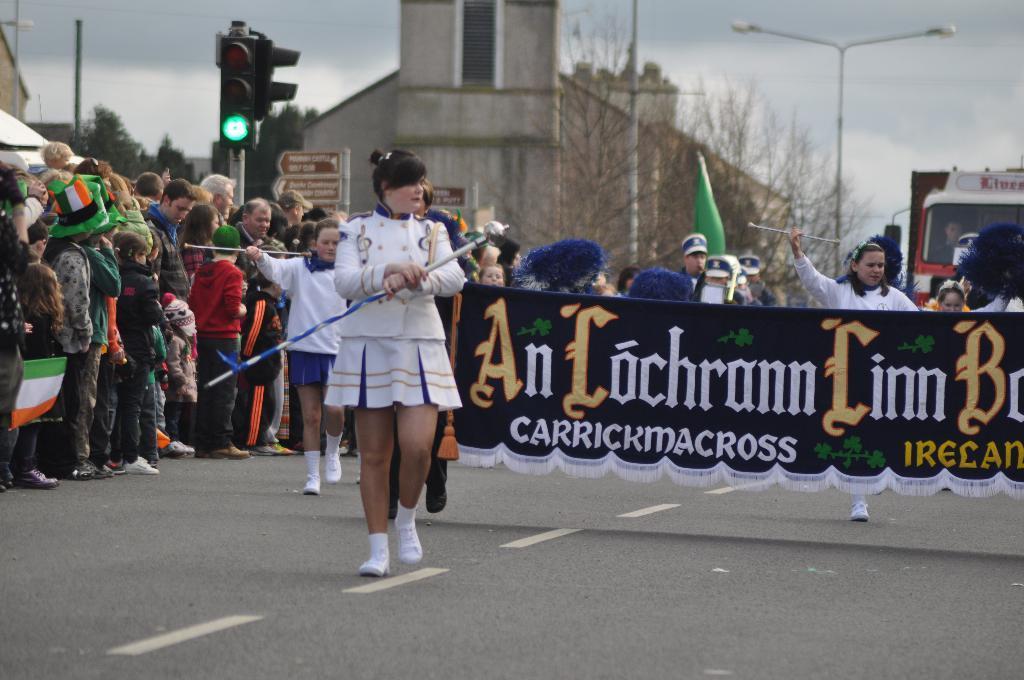Describe this image in one or two sentences. In this picture we can see a woman is walking and holding an object and behind the woman there are a group of people standing and some people are walking and some people are holding a banner. Behind the people there are poles with traffic signals and lights. Behind the poles there are buildings, a vehicle, trees and the sky. 